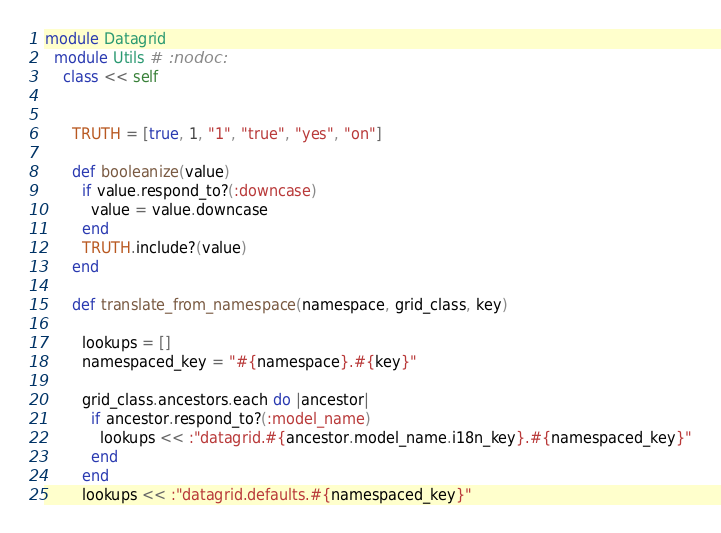Convert code to text. <code><loc_0><loc_0><loc_500><loc_500><_Ruby_>module Datagrid
  module Utils # :nodoc:
    class << self


      TRUTH = [true, 1, "1", "true", "yes", "on"]

      def booleanize(value)
        if value.respond_to?(:downcase)
          value = value.downcase
        end
        TRUTH.include?(value)
      end

      def translate_from_namespace(namespace, grid_class, key)

        lookups = []
        namespaced_key = "#{namespace}.#{key}"

        grid_class.ancestors.each do |ancestor|
          if ancestor.respond_to?(:model_name)
            lookups << :"datagrid.#{ancestor.model_name.i18n_key}.#{namespaced_key}"
          end
        end
        lookups << :"datagrid.defaults.#{namespaced_key}"</code> 